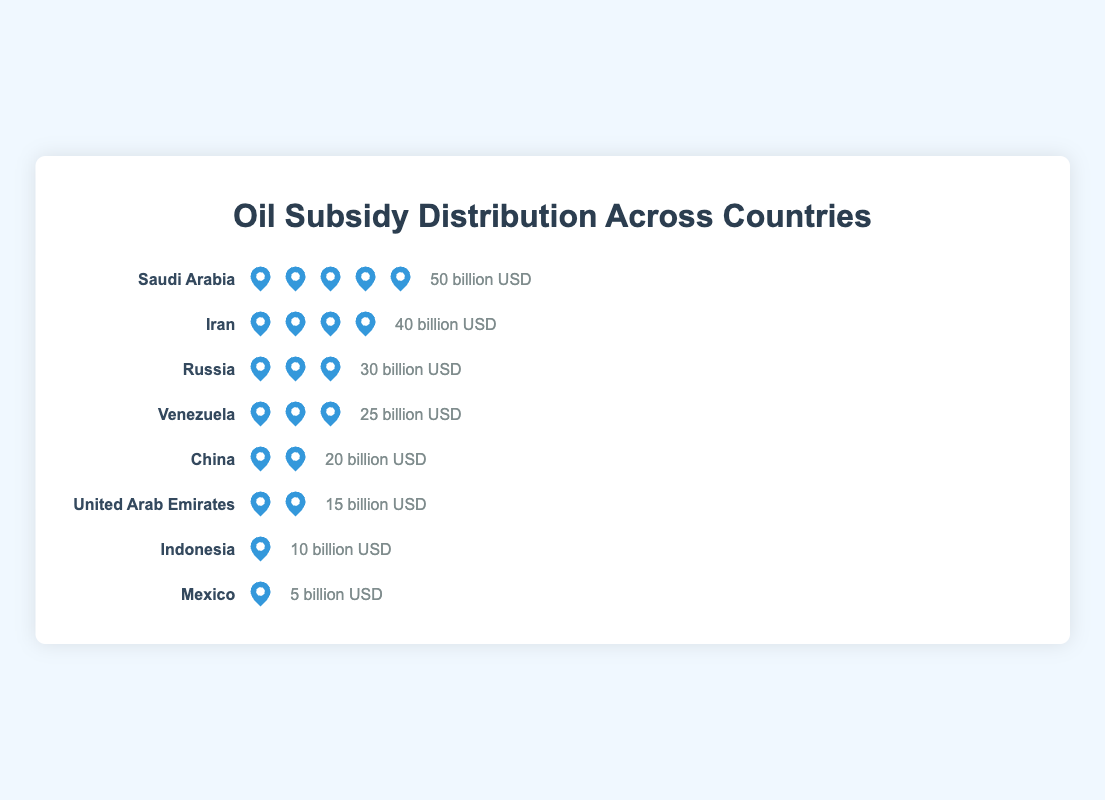What is the title of the plot? The title is displayed at the top of the plot, which describes the main subject of the visualized data.
Answer: Oil Subsidy Distribution Across Countries What is the subsidy amount for Saudi Arabia? The figure shows this information next to Saudi Arabia's row, with oil icons representing the subsidy amount and text indicating the exact number.
Answer: 50 billion USD Which country has the lowest oil subsidy amount? Observing the rows, Mexico has the fewest oil icons and the lowest numerical subsidy amount displayed next to it.
Answer: Mexico How many countries have a subsidy amount greater than or equal to 25 billion USD? Countries with amounts larger or equal to 25 billion USD can be identified by the number of oil icons (5, 4, or 3) and their subsidy amounts.
Answer: 4 (Saudi Arabia, Iran, Russia, Venezuela) What is the total subsidy amount for Iran and China combined? Add the subsidy amounts for Iran and China as shown in the figure (40 + 20).
Answer: 60 billion USD Which country has more subsidies, Russia or United Arab Emirates? Russia's row has more oil icons and a higher subsidy amount compared to United Arab Emirates.
Answer: Russia What is the average subsidy amount of all countries listed? Sum the subsidy amounts of all countries (50 + 40 + 30 + 25 + 20 + 15 + 10 + 5 = 195) and divide by the number of countries (195 / 8).
Answer: 24.375 billion USD Is Iran's subsidy amount exactly half of Saudi Arabia's subsidy amount? Compare Iran's subsidy amount (40 billion USD) to half of Saudi Arabia's subsidy amount (50 billion USD / 2 = 25 billion USD).
Answer: No By how much does Saudi Arabia's subsidy exceed that of Mexico? Subtract Mexico's subsidy amount from Saudi Arabia's (50 - 5).
Answer: 45 billion USD 